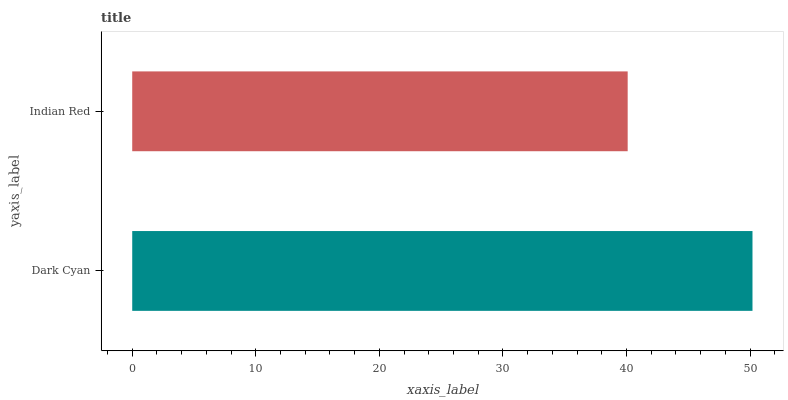Is Indian Red the minimum?
Answer yes or no. Yes. Is Dark Cyan the maximum?
Answer yes or no. Yes. Is Indian Red the maximum?
Answer yes or no. No. Is Dark Cyan greater than Indian Red?
Answer yes or no. Yes. Is Indian Red less than Dark Cyan?
Answer yes or no. Yes. Is Indian Red greater than Dark Cyan?
Answer yes or no. No. Is Dark Cyan less than Indian Red?
Answer yes or no. No. Is Dark Cyan the high median?
Answer yes or no. Yes. Is Indian Red the low median?
Answer yes or no. Yes. Is Indian Red the high median?
Answer yes or no. No. Is Dark Cyan the low median?
Answer yes or no. No. 